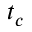Convert formula to latex. <formula><loc_0><loc_0><loc_500><loc_500>t _ { c }</formula> 